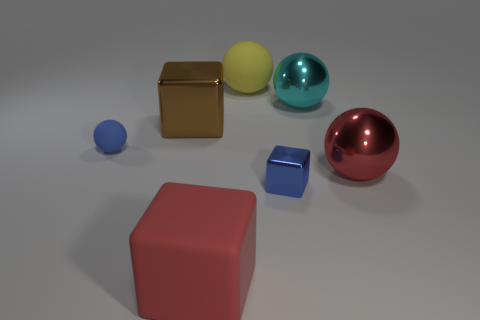Subtract all red shiny spheres. How many spheres are left? 3 Add 3 large cyan things. How many objects exist? 10 Subtract all cyan balls. How many balls are left? 3 Subtract all blocks. How many objects are left? 4 Subtract all gray blocks. Subtract all cyan cylinders. How many blocks are left? 3 Subtract all green cylinders. How many yellow blocks are left? 0 Subtract all small green rubber spheres. Subtract all cyan things. How many objects are left? 6 Add 3 large matte cubes. How many large matte cubes are left? 4 Add 1 tiny blue metallic spheres. How many tiny blue metallic spheres exist? 1 Subtract 0 purple balls. How many objects are left? 7 